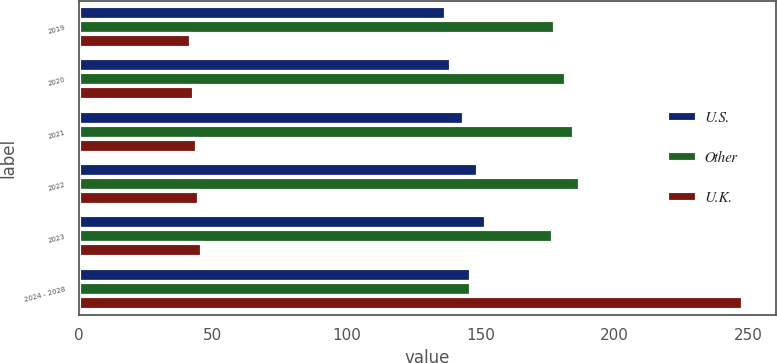Convert chart. <chart><loc_0><loc_0><loc_500><loc_500><stacked_bar_chart><ecel><fcel>2019<fcel>2020<fcel>2021<fcel>2022<fcel>2023<fcel>2024 - 2028<nl><fcel>U.S.<fcel>137<fcel>139<fcel>144<fcel>149<fcel>152<fcel>146.5<nl><fcel>Other<fcel>178<fcel>182<fcel>185<fcel>187<fcel>177<fcel>146.5<nl><fcel>U.K.<fcel>42<fcel>43<fcel>44<fcel>45<fcel>46<fcel>248<nl></chart> 